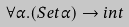<formula> <loc_0><loc_0><loc_500><loc_500>\forall \alpha . ( S e t \alpha ) \rightarrow i n t</formula> 